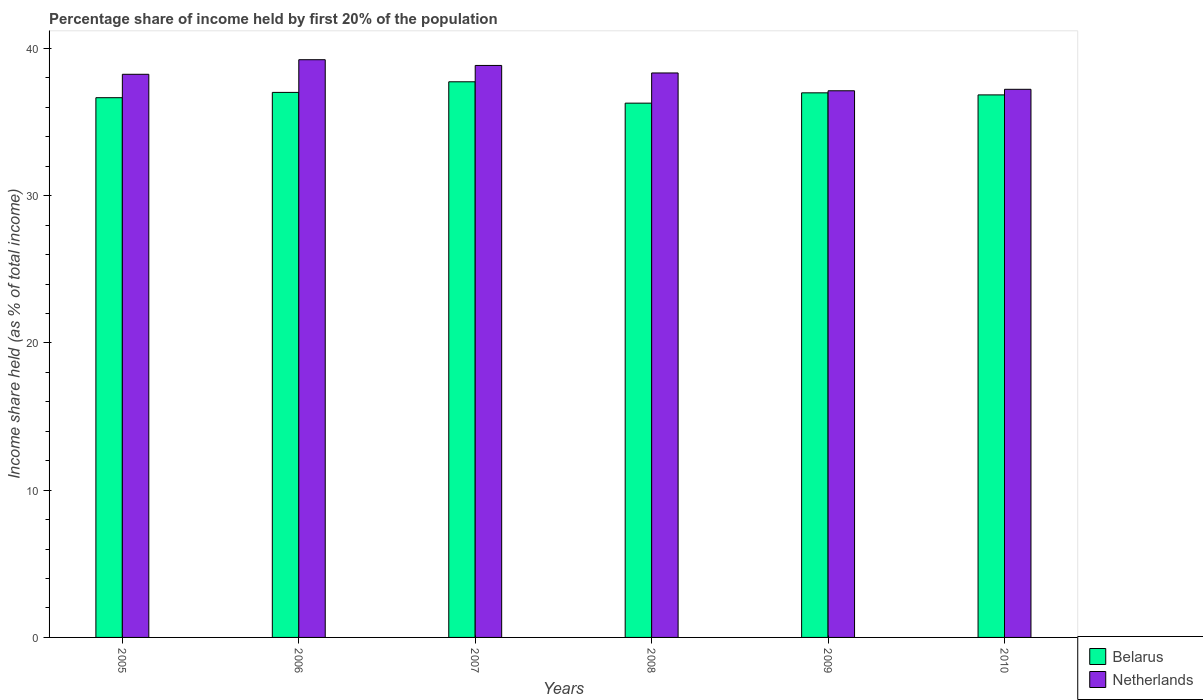How many different coloured bars are there?
Your answer should be compact. 2. How many groups of bars are there?
Give a very brief answer. 6. Are the number of bars per tick equal to the number of legend labels?
Your answer should be very brief. Yes. In how many cases, is the number of bars for a given year not equal to the number of legend labels?
Offer a very short reply. 0. What is the share of income held by first 20% of the population in Belarus in 2010?
Your answer should be very brief. 36.85. Across all years, what is the maximum share of income held by first 20% of the population in Netherlands?
Your response must be concise. 39.24. Across all years, what is the minimum share of income held by first 20% of the population in Netherlands?
Your answer should be compact. 37.13. In which year was the share of income held by first 20% of the population in Belarus maximum?
Offer a terse response. 2007. What is the total share of income held by first 20% of the population in Netherlands in the graph?
Offer a terse response. 229.04. What is the difference between the share of income held by first 20% of the population in Belarus in 2006 and that in 2007?
Offer a very short reply. -0.72. What is the difference between the share of income held by first 20% of the population in Belarus in 2007 and the share of income held by first 20% of the population in Netherlands in 2009?
Your answer should be very brief. 0.61. What is the average share of income held by first 20% of the population in Belarus per year?
Offer a very short reply. 36.93. In the year 2005, what is the difference between the share of income held by first 20% of the population in Netherlands and share of income held by first 20% of the population in Belarus?
Make the answer very short. 1.59. What is the ratio of the share of income held by first 20% of the population in Belarus in 2008 to that in 2009?
Offer a very short reply. 0.98. Is the difference between the share of income held by first 20% of the population in Netherlands in 2008 and 2009 greater than the difference between the share of income held by first 20% of the population in Belarus in 2008 and 2009?
Offer a terse response. Yes. What is the difference between the highest and the second highest share of income held by first 20% of the population in Netherlands?
Give a very brief answer. 0.39. What is the difference between the highest and the lowest share of income held by first 20% of the population in Belarus?
Make the answer very short. 1.45. Is the sum of the share of income held by first 20% of the population in Netherlands in 2006 and 2008 greater than the maximum share of income held by first 20% of the population in Belarus across all years?
Your response must be concise. Yes. How many bars are there?
Provide a succinct answer. 12. What is the difference between two consecutive major ticks on the Y-axis?
Your response must be concise. 10. Are the values on the major ticks of Y-axis written in scientific E-notation?
Make the answer very short. No. Does the graph contain any zero values?
Your response must be concise. No. How are the legend labels stacked?
Provide a succinct answer. Vertical. What is the title of the graph?
Keep it short and to the point. Percentage share of income held by first 20% of the population. What is the label or title of the Y-axis?
Offer a very short reply. Income share held (as % of total income). What is the Income share held (as % of total income) in Belarus in 2005?
Ensure brevity in your answer.  36.66. What is the Income share held (as % of total income) of Netherlands in 2005?
Your answer should be compact. 38.25. What is the Income share held (as % of total income) in Belarus in 2006?
Provide a succinct answer. 37.02. What is the Income share held (as % of total income) in Netherlands in 2006?
Your answer should be compact. 39.24. What is the Income share held (as % of total income) of Belarus in 2007?
Your response must be concise. 37.74. What is the Income share held (as % of total income) in Netherlands in 2007?
Ensure brevity in your answer.  38.85. What is the Income share held (as % of total income) in Belarus in 2008?
Offer a terse response. 36.29. What is the Income share held (as % of total income) of Netherlands in 2008?
Offer a terse response. 38.34. What is the Income share held (as % of total income) in Belarus in 2009?
Ensure brevity in your answer.  36.99. What is the Income share held (as % of total income) of Netherlands in 2009?
Provide a succinct answer. 37.13. What is the Income share held (as % of total income) of Belarus in 2010?
Offer a very short reply. 36.85. What is the Income share held (as % of total income) of Netherlands in 2010?
Provide a short and direct response. 37.23. Across all years, what is the maximum Income share held (as % of total income) of Belarus?
Your answer should be very brief. 37.74. Across all years, what is the maximum Income share held (as % of total income) in Netherlands?
Your response must be concise. 39.24. Across all years, what is the minimum Income share held (as % of total income) of Belarus?
Make the answer very short. 36.29. Across all years, what is the minimum Income share held (as % of total income) in Netherlands?
Ensure brevity in your answer.  37.13. What is the total Income share held (as % of total income) in Belarus in the graph?
Keep it short and to the point. 221.55. What is the total Income share held (as % of total income) of Netherlands in the graph?
Offer a very short reply. 229.04. What is the difference between the Income share held (as % of total income) of Belarus in 2005 and that in 2006?
Ensure brevity in your answer.  -0.36. What is the difference between the Income share held (as % of total income) of Netherlands in 2005 and that in 2006?
Give a very brief answer. -0.99. What is the difference between the Income share held (as % of total income) of Belarus in 2005 and that in 2007?
Provide a short and direct response. -1.08. What is the difference between the Income share held (as % of total income) of Netherlands in 2005 and that in 2007?
Keep it short and to the point. -0.6. What is the difference between the Income share held (as % of total income) in Belarus in 2005 and that in 2008?
Provide a succinct answer. 0.37. What is the difference between the Income share held (as % of total income) of Netherlands in 2005 and that in 2008?
Provide a short and direct response. -0.09. What is the difference between the Income share held (as % of total income) of Belarus in 2005 and that in 2009?
Ensure brevity in your answer.  -0.33. What is the difference between the Income share held (as % of total income) of Netherlands in 2005 and that in 2009?
Keep it short and to the point. 1.12. What is the difference between the Income share held (as % of total income) in Belarus in 2005 and that in 2010?
Offer a terse response. -0.19. What is the difference between the Income share held (as % of total income) of Netherlands in 2005 and that in 2010?
Your response must be concise. 1.02. What is the difference between the Income share held (as % of total income) in Belarus in 2006 and that in 2007?
Provide a short and direct response. -0.72. What is the difference between the Income share held (as % of total income) in Netherlands in 2006 and that in 2007?
Your answer should be compact. 0.39. What is the difference between the Income share held (as % of total income) in Belarus in 2006 and that in 2008?
Provide a short and direct response. 0.73. What is the difference between the Income share held (as % of total income) of Netherlands in 2006 and that in 2008?
Your answer should be very brief. 0.9. What is the difference between the Income share held (as % of total income) of Netherlands in 2006 and that in 2009?
Offer a terse response. 2.11. What is the difference between the Income share held (as % of total income) of Belarus in 2006 and that in 2010?
Your answer should be very brief. 0.17. What is the difference between the Income share held (as % of total income) of Netherlands in 2006 and that in 2010?
Your answer should be compact. 2.01. What is the difference between the Income share held (as % of total income) of Belarus in 2007 and that in 2008?
Your response must be concise. 1.45. What is the difference between the Income share held (as % of total income) in Netherlands in 2007 and that in 2008?
Make the answer very short. 0.51. What is the difference between the Income share held (as % of total income) of Belarus in 2007 and that in 2009?
Your response must be concise. 0.75. What is the difference between the Income share held (as % of total income) of Netherlands in 2007 and that in 2009?
Ensure brevity in your answer.  1.72. What is the difference between the Income share held (as % of total income) of Belarus in 2007 and that in 2010?
Provide a short and direct response. 0.89. What is the difference between the Income share held (as % of total income) in Netherlands in 2007 and that in 2010?
Offer a very short reply. 1.62. What is the difference between the Income share held (as % of total income) of Belarus in 2008 and that in 2009?
Provide a succinct answer. -0.7. What is the difference between the Income share held (as % of total income) in Netherlands in 2008 and that in 2009?
Keep it short and to the point. 1.21. What is the difference between the Income share held (as % of total income) of Belarus in 2008 and that in 2010?
Your answer should be compact. -0.56. What is the difference between the Income share held (as % of total income) of Netherlands in 2008 and that in 2010?
Keep it short and to the point. 1.11. What is the difference between the Income share held (as % of total income) in Belarus in 2009 and that in 2010?
Your answer should be very brief. 0.14. What is the difference between the Income share held (as % of total income) of Belarus in 2005 and the Income share held (as % of total income) of Netherlands in 2006?
Your answer should be compact. -2.58. What is the difference between the Income share held (as % of total income) in Belarus in 2005 and the Income share held (as % of total income) in Netherlands in 2007?
Your response must be concise. -2.19. What is the difference between the Income share held (as % of total income) of Belarus in 2005 and the Income share held (as % of total income) of Netherlands in 2008?
Provide a succinct answer. -1.68. What is the difference between the Income share held (as % of total income) of Belarus in 2005 and the Income share held (as % of total income) of Netherlands in 2009?
Your answer should be very brief. -0.47. What is the difference between the Income share held (as % of total income) of Belarus in 2005 and the Income share held (as % of total income) of Netherlands in 2010?
Make the answer very short. -0.57. What is the difference between the Income share held (as % of total income) of Belarus in 2006 and the Income share held (as % of total income) of Netherlands in 2007?
Keep it short and to the point. -1.83. What is the difference between the Income share held (as % of total income) in Belarus in 2006 and the Income share held (as % of total income) in Netherlands in 2008?
Your answer should be very brief. -1.32. What is the difference between the Income share held (as % of total income) in Belarus in 2006 and the Income share held (as % of total income) in Netherlands in 2009?
Offer a terse response. -0.11. What is the difference between the Income share held (as % of total income) in Belarus in 2006 and the Income share held (as % of total income) in Netherlands in 2010?
Keep it short and to the point. -0.21. What is the difference between the Income share held (as % of total income) in Belarus in 2007 and the Income share held (as % of total income) in Netherlands in 2009?
Your answer should be compact. 0.61. What is the difference between the Income share held (as % of total income) in Belarus in 2007 and the Income share held (as % of total income) in Netherlands in 2010?
Your answer should be very brief. 0.51. What is the difference between the Income share held (as % of total income) of Belarus in 2008 and the Income share held (as % of total income) of Netherlands in 2009?
Provide a short and direct response. -0.84. What is the difference between the Income share held (as % of total income) of Belarus in 2008 and the Income share held (as % of total income) of Netherlands in 2010?
Offer a terse response. -0.94. What is the difference between the Income share held (as % of total income) in Belarus in 2009 and the Income share held (as % of total income) in Netherlands in 2010?
Your answer should be very brief. -0.24. What is the average Income share held (as % of total income) of Belarus per year?
Your answer should be very brief. 36.92. What is the average Income share held (as % of total income) in Netherlands per year?
Ensure brevity in your answer.  38.17. In the year 2005, what is the difference between the Income share held (as % of total income) in Belarus and Income share held (as % of total income) in Netherlands?
Provide a succinct answer. -1.59. In the year 2006, what is the difference between the Income share held (as % of total income) in Belarus and Income share held (as % of total income) in Netherlands?
Give a very brief answer. -2.22. In the year 2007, what is the difference between the Income share held (as % of total income) in Belarus and Income share held (as % of total income) in Netherlands?
Your response must be concise. -1.11. In the year 2008, what is the difference between the Income share held (as % of total income) of Belarus and Income share held (as % of total income) of Netherlands?
Offer a very short reply. -2.05. In the year 2009, what is the difference between the Income share held (as % of total income) in Belarus and Income share held (as % of total income) in Netherlands?
Provide a succinct answer. -0.14. In the year 2010, what is the difference between the Income share held (as % of total income) of Belarus and Income share held (as % of total income) of Netherlands?
Your answer should be compact. -0.38. What is the ratio of the Income share held (as % of total income) of Belarus in 2005 to that in 2006?
Provide a succinct answer. 0.99. What is the ratio of the Income share held (as % of total income) in Netherlands in 2005 to that in 2006?
Your answer should be compact. 0.97. What is the ratio of the Income share held (as % of total income) of Belarus in 2005 to that in 2007?
Give a very brief answer. 0.97. What is the ratio of the Income share held (as % of total income) in Netherlands in 2005 to that in 2007?
Provide a succinct answer. 0.98. What is the ratio of the Income share held (as % of total income) in Belarus in 2005 to that in 2008?
Give a very brief answer. 1.01. What is the ratio of the Income share held (as % of total income) in Netherlands in 2005 to that in 2009?
Provide a succinct answer. 1.03. What is the ratio of the Income share held (as % of total income) of Netherlands in 2005 to that in 2010?
Offer a very short reply. 1.03. What is the ratio of the Income share held (as % of total income) of Belarus in 2006 to that in 2007?
Offer a terse response. 0.98. What is the ratio of the Income share held (as % of total income) in Netherlands in 2006 to that in 2007?
Your answer should be very brief. 1.01. What is the ratio of the Income share held (as % of total income) of Belarus in 2006 to that in 2008?
Make the answer very short. 1.02. What is the ratio of the Income share held (as % of total income) of Netherlands in 2006 to that in 2008?
Your answer should be compact. 1.02. What is the ratio of the Income share held (as % of total income) in Belarus in 2006 to that in 2009?
Offer a terse response. 1. What is the ratio of the Income share held (as % of total income) in Netherlands in 2006 to that in 2009?
Offer a very short reply. 1.06. What is the ratio of the Income share held (as % of total income) of Netherlands in 2006 to that in 2010?
Offer a terse response. 1.05. What is the ratio of the Income share held (as % of total income) in Belarus in 2007 to that in 2008?
Your response must be concise. 1.04. What is the ratio of the Income share held (as % of total income) of Netherlands in 2007 to that in 2008?
Your answer should be very brief. 1.01. What is the ratio of the Income share held (as % of total income) of Belarus in 2007 to that in 2009?
Your answer should be very brief. 1.02. What is the ratio of the Income share held (as % of total income) of Netherlands in 2007 to that in 2009?
Provide a short and direct response. 1.05. What is the ratio of the Income share held (as % of total income) in Belarus in 2007 to that in 2010?
Offer a terse response. 1.02. What is the ratio of the Income share held (as % of total income) in Netherlands in 2007 to that in 2010?
Keep it short and to the point. 1.04. What is the ratio of the Income share held (as % of total income) of Belarus in 2008 to that in 2009?
Your response must be concise. 0.98. What is the ratio of the Income share held (as % of total income) of Netherlands in 2008 to that in 2009?
Provide a short and direct response. 1.03. What is the ratio of the Income share held (as % of total income) in Netherlands in 2008 to that in 2010?
Ensure brevity in your answer.  1.03. What is the ratio of the Income share held (as % of total income) of Belarus in 2009 to that in 2010?
Ensure brevity in your answer.  1. What is the difference between the highest and the second highest Income share held (as % of total income) in Belarus?
Offer a very short reply. 0.72. What is the difference between the highest and the second highest Income share held (as % of total income) in Netherlands?
Ensure brevity in your answer.  0.39. What is the difference between the highest and the lowest Income share held (as % of total income) of Belarus?
Keep it short and to the point. 1.45. What is the difference between the highest and the lowest Income share held (as % of total income) of Netherlands?
Your answer should be very brief. 2.11. 